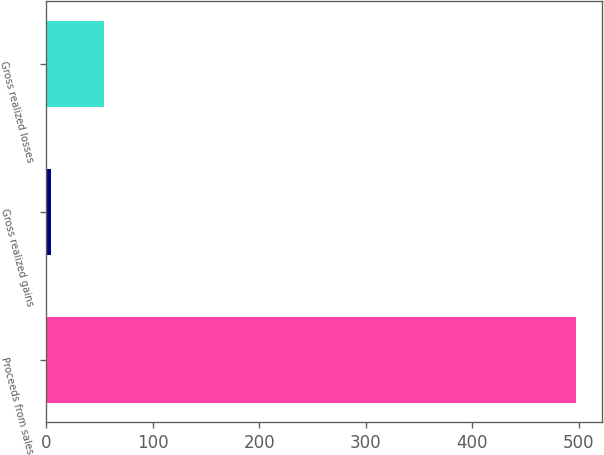Convert chart to OTSL. <chart><loc_0><loc_0><loc_500><loc_500><bar_chart><fcel>Proceeds from sales<fcel>Gross realized gains<fcel>Gross realized losses<nl><fcel>497<fcel>5<fcel>54.2<nl></chart> 